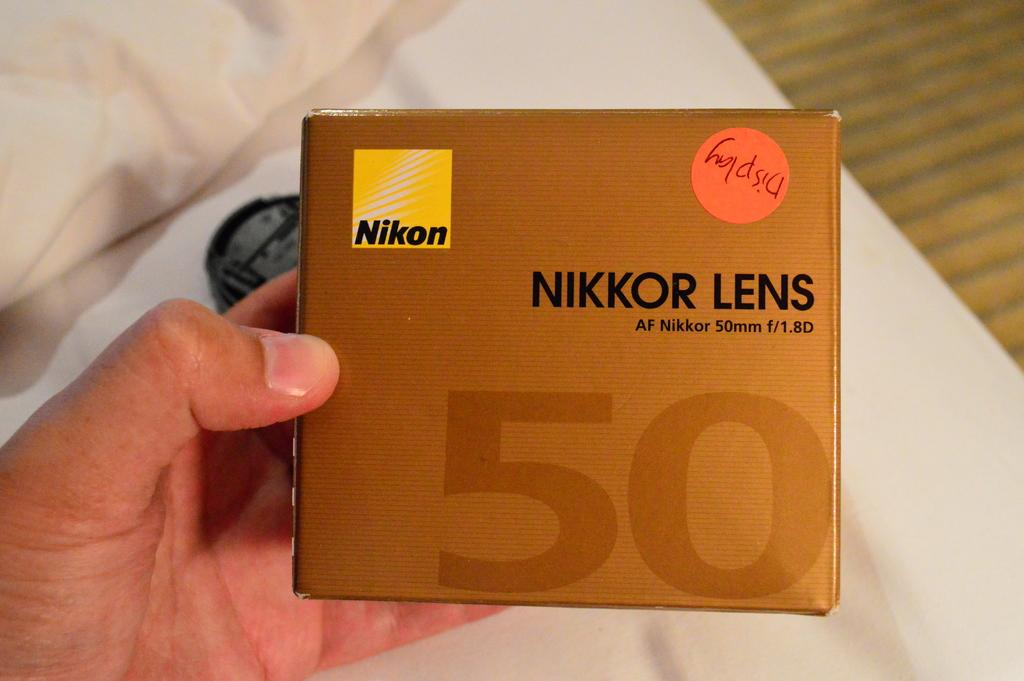<image>
Write a terse but informative summary of the picture. nikon lens 50 brand new in the box 